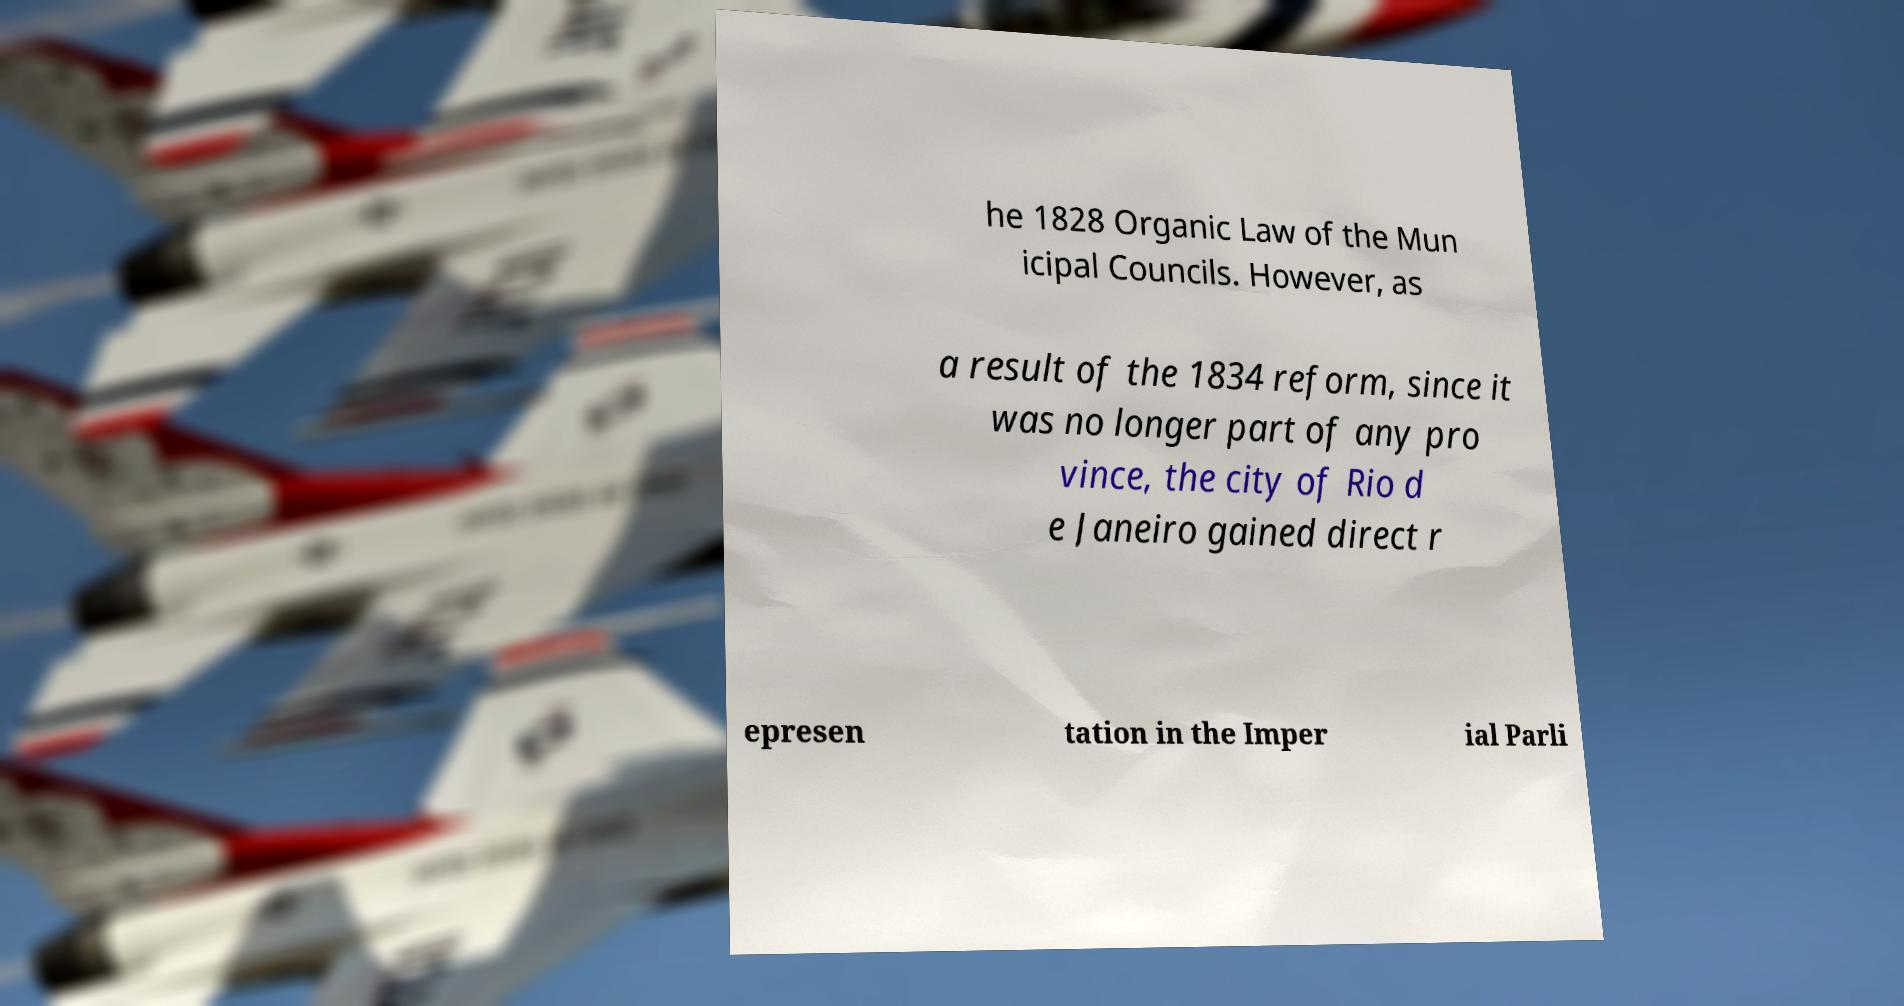Please identify and transcribe the text found in this image. he 1828 Organic Law of the Mun icipal Councils. However, as a result of the 1834 reform, since it was no longer part of any pro vince, the city of Rio d e Janeiro gained direct r epresen tation in the Imper ial Parli 